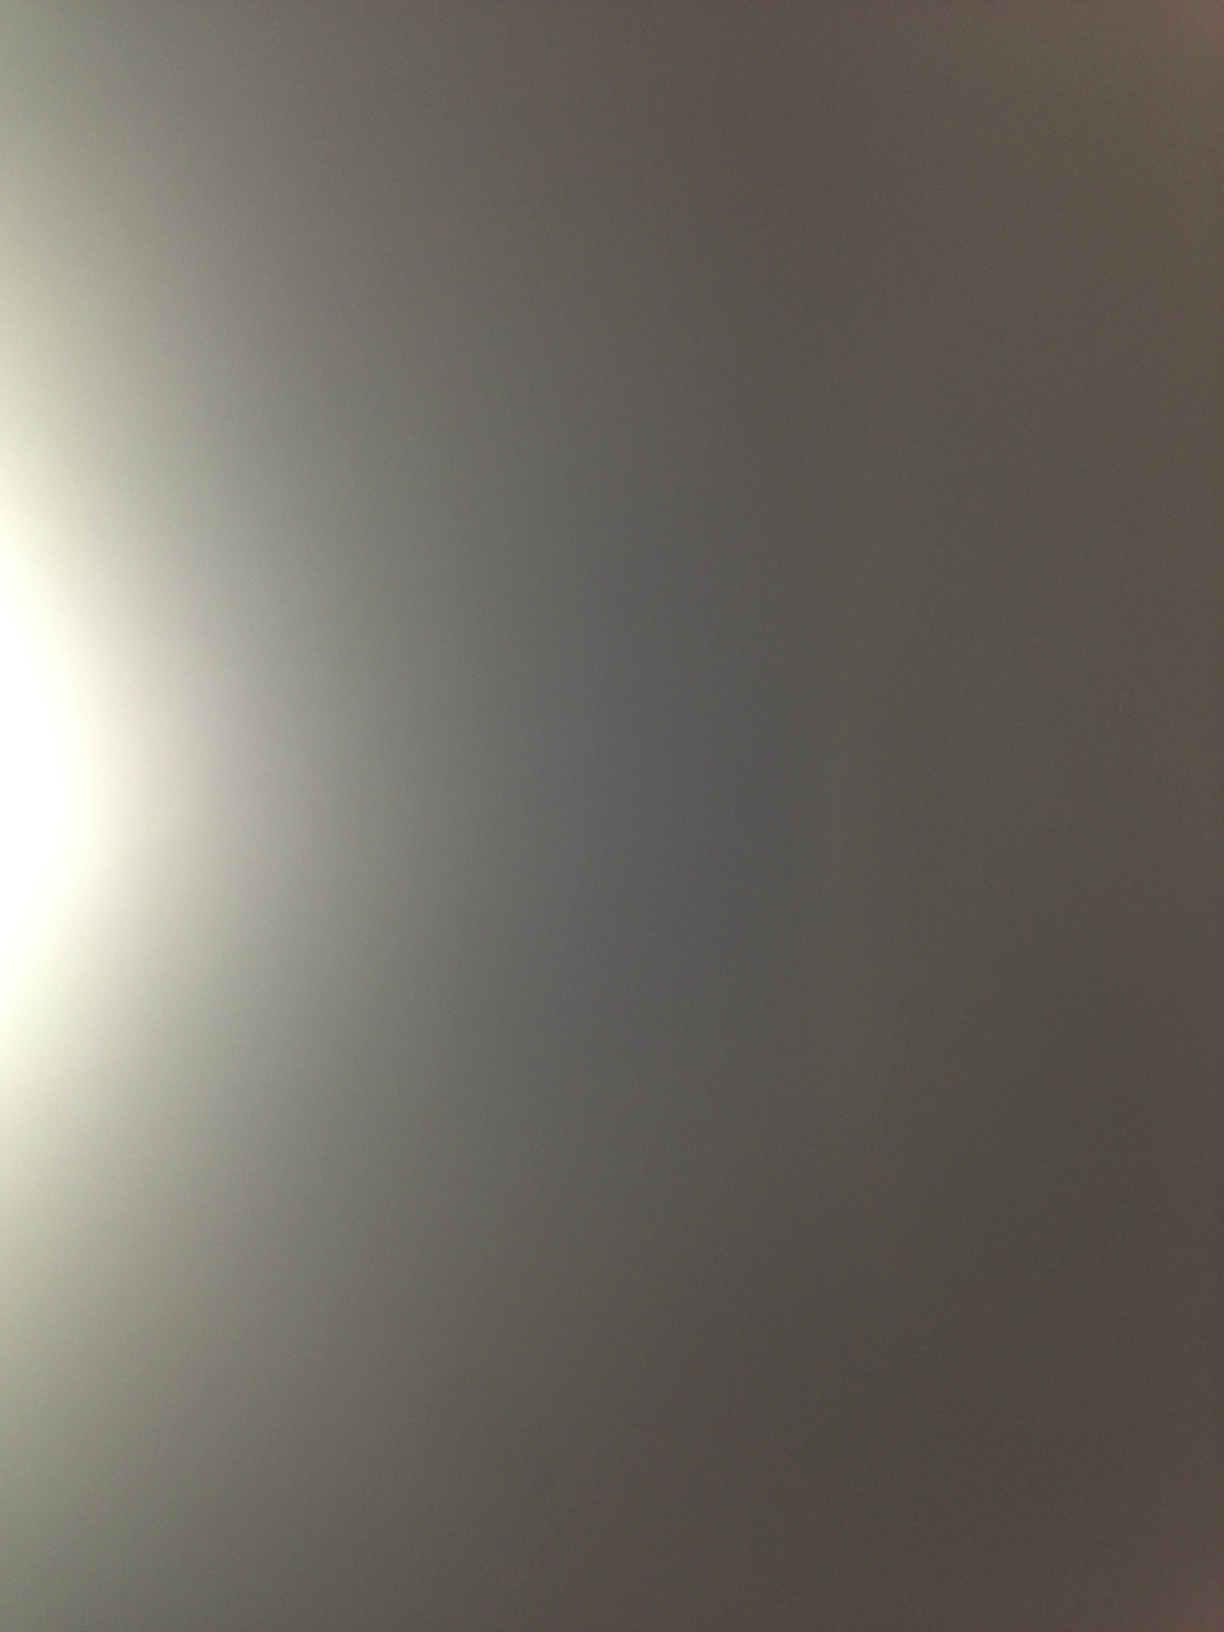What is my favorite dog? The question is based on personal preference, and it is unanswerable solely based on the image provided. 